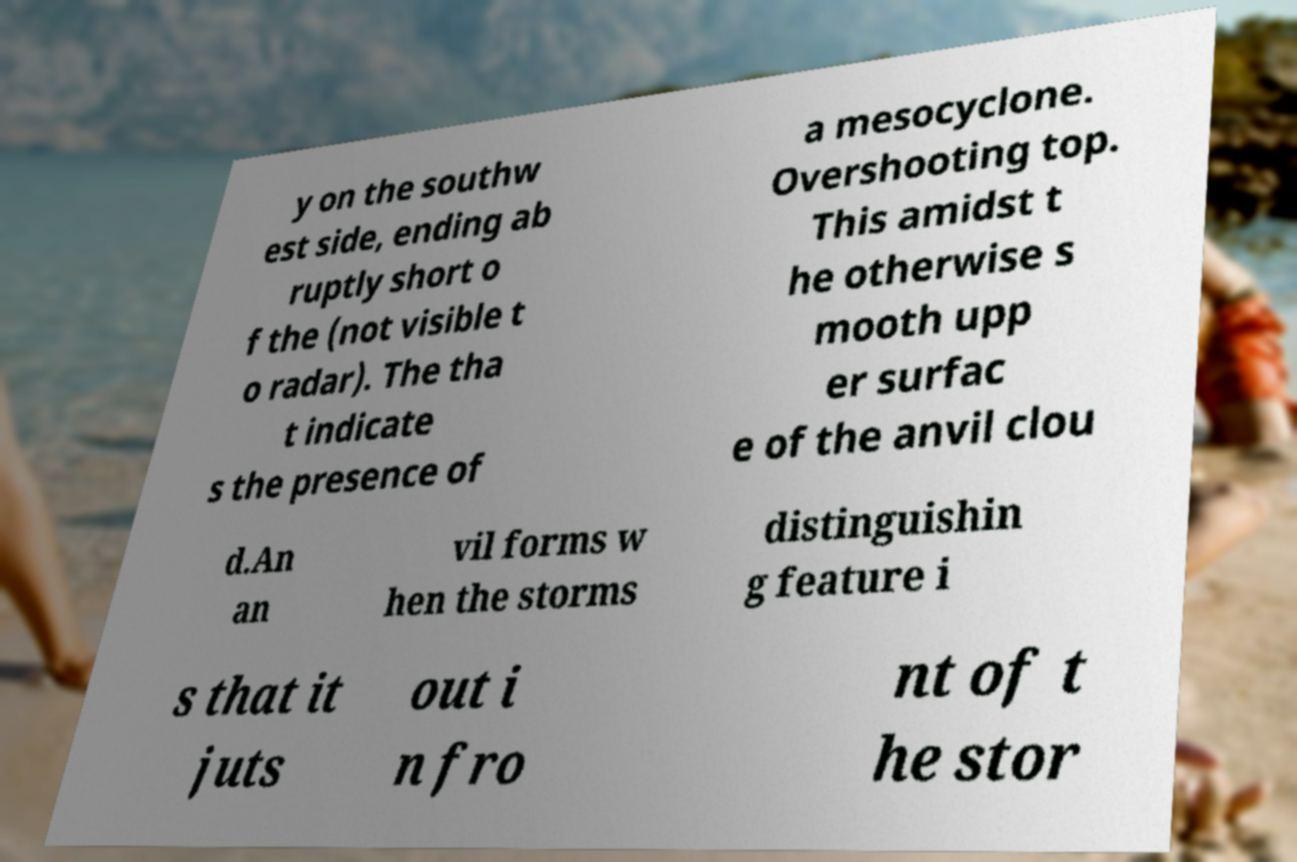Can you accurately transcribe the text from the provided image for me? y on the southw est side, ending ab ruptly short o f the (not visible t o radar). The tha t indicate s the presence of a mesocyclone. Overshooting top. This amidst t he otherwise s mooth upp er surfac e of the anvil clou d.An an vil forms w hen the storms distinguishin g feature i s that it juts out i n fro nt of t he stor 